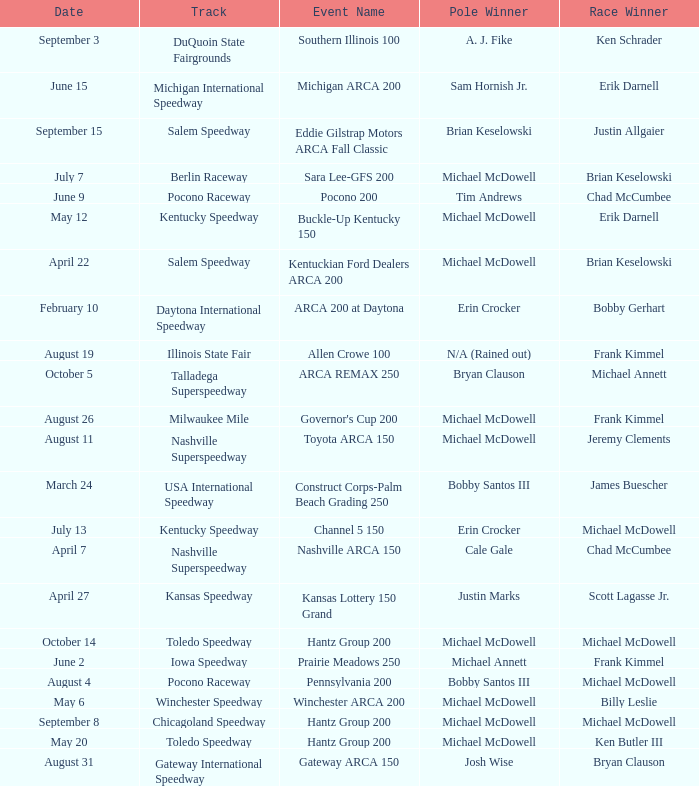Tell me the event name for michael mcdowell and billy leslie Winchester ARCA 200. 